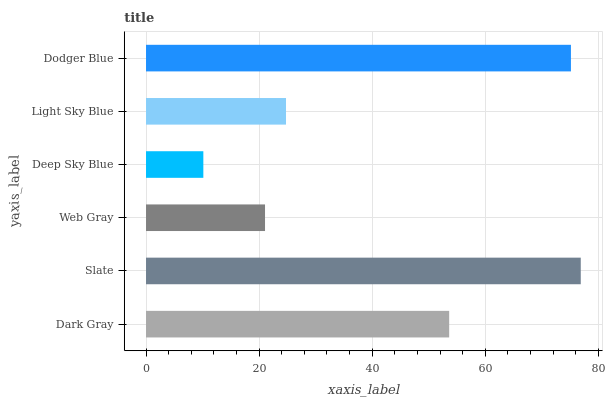Is Deep Sky Blue the minimum?
Answer yes or no. Yes. Is Slate the maximum?
Answer yes or no. Yes. Is Web Gray the minimum?
Answer yes or no. No. Is Web Gray the maximum?
Answer yes or no. No. Is Slate greater than Web Gray?
Answer yes or no. Yes. Is Web Gray less than Slate?
Answer yes or no. Yes. Is Web Gray greater than Slate?
Answer yes or no. No. Is Slate less than Web Gray?
Answer yes or no. No. Is Dark Gray the high median?
Answer yes or no. Yes. Is Light Sky Blue the low median?
Answer yes or no. Yes. Is Slate the high median?
Answer yes or no. No. Is Deep Sky Blue the low median?
Answer yes or no. No. 